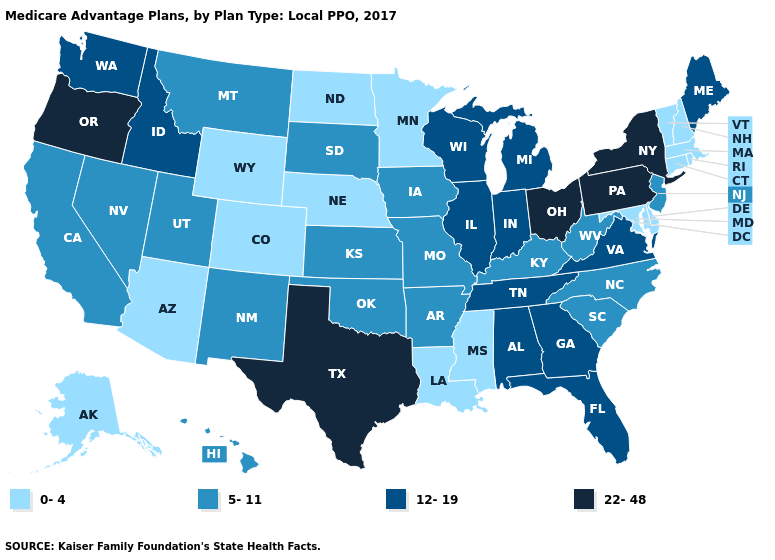Which states hav the highest value in the West?
Answer briefly. Oregon. Among the states that border Wisconsin , does Minnesota have the lowest value?
Concise answer only. Yes. Name the states that have a value in the range 0-4?
Write a very short answer. Alaska, Arizona, Colorado, Connecticut, Delaware, Louisiana, Massachusetts, Maryland, Minnesota, Mississippi, North Dakota, Nebraska, New Hampshire, Rhode Island, Vermont, Wyoming. Name the states that have a value in the range 12-19?
Give a very brief answer. Alabama, Florida, Georgia, Idaho, Illinois, Indiana, Maine, Michigan, Tennessee, Virginia, Washington, Wisconsin. Among the states that border Georgia , does Tennessee have the lowest value?
Short answer required. No. Among the states that border New York , does New Jersey have the lowest value?
Quick response, please. No. Does Georgia have a lower value than Texas?
Quick response, please. Yes. Among the states that border Ohio , which have the lowest value?
Quick response, please. Kentucky, West Virginia. Name the states that have a value in the range 12-19?
Short answer required. Alabama, Florida, Georgia, Idaho, Illinois, Indiana, Maine, Michigan, Tennessee, Virginia, Washington, Wisconsin. Does Oklahoma have a lower value than Alabama?
Write a very short answer. Yes. What is the value of Michigan?
Answer briefly. 12-19. Does Vermont have the same value as Mississippi?
Give a very brief answer. Yes. What is the lowest value in the USA?
Keep it brief. 0-4. Does the map have missing data?
Answer briefly. No. 